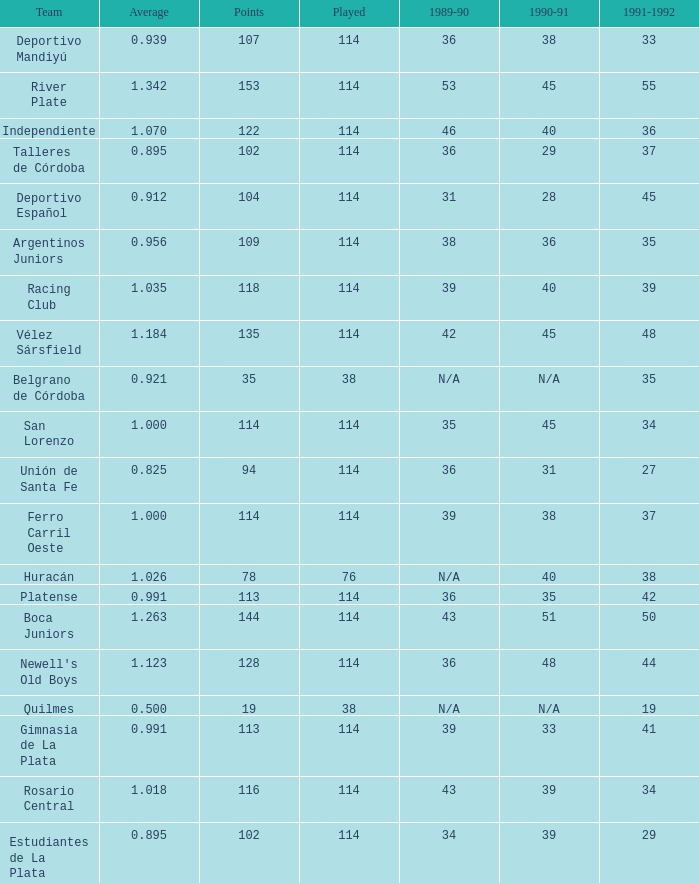How much 1991-1992 has a Team of gimnasia de la plata, and more than 113 points? 0.0. Can you give me this table as a dict? {'header': ['Team', 'Average', 'Points', 'Played', '1989-90', '1990-91', '1991-1992'], 'rows': [['Deportivo Mandiyú', '0.939', '107', '114', '36', '38', '33'], ['River Plate', '1.342', '153', '114', '53', '45', '55'], ['Independiente', '1.070', '122', '114', '46', '40', '36'], ['Talleres de Córdoba', '0.895', '102', '114', '36', '29', '37'], ['Deportivo Español', '0.912', '104', '114', '31', '28', '45'], ['Argentinos Juniors', '0.956', '109', '114', '38', '36', '35'], ['Racing Club', '1.035', '118', '114', '39', '40', '39'], ['Vélez Sársfield', '1.184', '135', '114', '42', '45', '48'], ['Belgrano de Córdoba', '0.921', '35', '38', 'N/A', 'N/A', '35'], ['San Lorenzo', '1.000', '114', '114', '35', '45', '34'], ['Unión de Santa Fe', '0.825', '94', '114', '36', '31', '27'], ['Ferro Carril Oeste', '1.000', '114', '114', '39', '38', '37'], ['Huracán', '1.026', '78', '76', 'N/A', '40', '38'], ['Platense', '0.991', '113', '114', '36', '35', '42'], ['Boca Juniors', '1.263', '144', '114', '43', '51', '50'], ["Newell's Old Boys", '1.123', '128', '114', '36', '48', '44'], ['Quilmes', '0.500', '19', '38', 'N/A', 'N/A', '19'], ['Gimnasia de La Plata', '0.991', '113', '114', '39', '33', '41'], ['Rosario Central', '1.018', '116', '114', '43', '39', '34'], ['Estudiantes de La Plata', '0.895', '102', '114', '34', '39', '29']]} 